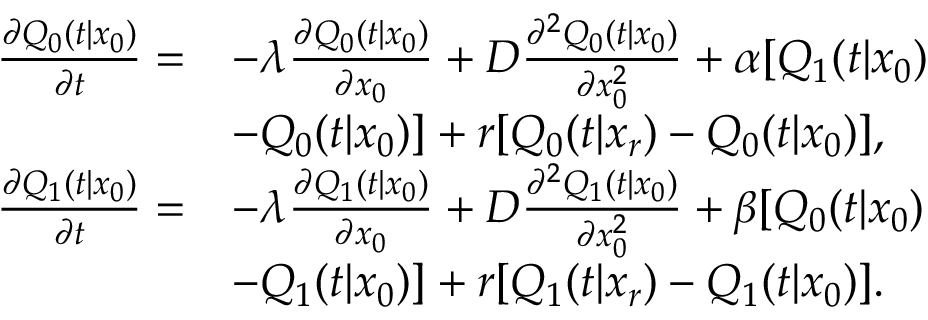<formula> <loc_0><loc_0><loc_500><loc_500>\begin{array} { r l } { \frac { \partial Q _ { 0 } ( t | x _ { 0 } ) } { \partial t } = } & { - \lambda \frac { \partial Q _ { 0 } ( t | x _ { 0 } ) } { \partial x _ { 0 } } + D \frac { \partial ^ { 2 } Q _ { 0 } ( t | x _ { 0 } ) } { \partial x _ { 0 } ^ { 2 } } + \alpha [ Q _ { 1 } ( t | x _ { 0 } ) } \\ & { - Q _ { 0 } ( t | x _ { 0 } ) ] + r [ Q _ { 0 } ( t | x _ { r } ) - Q _ { 0 } ( t | x _ { 0 } ) ] , } \\ { \frac { \partial Q _ { 1 } ( t | x _ { 0 } ) } { \partial t } = } & { - \lambda \frac { \partial Q _ { 1 } ( t | x _ { 0 } ) } { \partial x _ { 0 } } + D \frac { \partial ^ { 2 } Q _ { 1 } ( t | x _ { 0 } ) } { \partial x _ { 0 } ^ { 2 } } + \beta [ Q _ { 0 } ( t | x _ { 0 } ) } \\ & { - Q _ { 1 } ( t | x _ { 0 } ) ] + r [ Q _ { 1 } ( t | x _ { r } ) - Q _ { 1 } ( t | x _ { 0 } ) ] . } \end{array}</formula> 